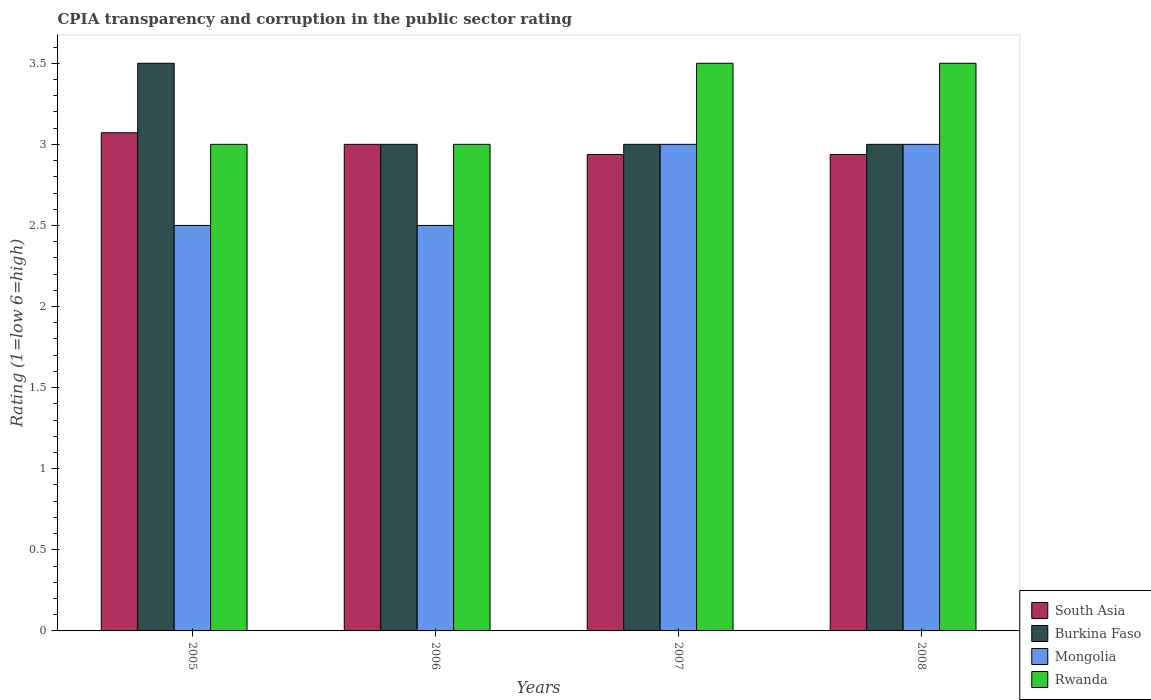How many different coloured bars are there?
Give a very brief answer. 4. Are the number of bars per tick equal to the number of legend labels?
Make the answer very short. Yes. How many bars are there on the 1st tick from the left?
Ensure brevity in your answer.  4. How many bars are there on the 4th tick from the right?
Your response must be concise. 4. What is the label of the 4th group of bars from the left?
Provide a short and direct response. 2008. In how many cases, is the number of bars for a given year not equal to the number of legend labels?
Keep it short and to the point. 0. What is the CPIA rating in Burkina Faso in 2008?
Provide a short and direct response. 3. Across all years, what is the maximum CPIA rating in Burkina Faso?
Make the answer very short. 3.5. Across all years, what is the minimum CPIA rating in South Asia?
Offer a terse response. 2.94. In which year was the CPIA rating in Burkina Faso maximum?
Provide a short and direct response. 2005. What is the difference between the CPIA rating in Burkina Faso in 2008 and the CPIA rating in South Asia in 2007?
Your answer should be very brief. 0.06. What is the average CPIA rating in Mongolia per year?
Provide a succinct answer. 2.75. In the year 2007, what is the difference between the CPIA rating in South Asia and CPIA rating in Burkina Faso?
Offer a terse response. -0.06. In how many years, is the CPIA rating in Mongolia greater than 1.6?
Ensure brevity in your answer.  4. What is the ratio of the CPIA rating in Mongolia in 2006 to that in 2007?
Your response must be concise. 0.83. Is the CPIA rating in Rwanda in 2005 less than that in 2007?
Your answer should be very brief. Yes. What is the difference between the highest and the second highest CPIA rating in Burkina Faso?
Provide a short and direct response. 0.5. What is the difference between the highest and the lowest CPIA rating in Rwanda?
Offer a very short reply. 0.5. Is it the case that in every year, the sum of the CPIA rating in Rwanda and CPIA rating in Mongolia is greater than the sum of CPIA rating in Burkina Faso and CPIA rating in South Asia?
Your answer should be very brief. No. What does the 4th bar from the left in 2008 represents?
Give a very brief answer. Rwanda. What does the 3rd bar from the right in 2008 represents?
Offer a very short reply. Burkina Faso. Is it the case that in every year, the sum of the CPIA rating in Mongolia and CPIA rating in Rwanda is greater than the CPIA rating in Burkina Faso?
Your response must be concise. Yes. How many bars are there?
Ensure brevity in your answer.  16. Are all the bars in the graph horizontal?
Your response must be concise. No. Are the values on the major ticks of Y-axis written in scientific E-notation?
Ensure brevity in your answer.  No. Does the graph contain any zero values?
Ensure brevity in your answer.  No. Where does the legend appear in the graph?
Ensure brevity in your answer.  Bottom right. How many legend labels are there?
Your answer should be compact. 4. How are the legend labels stacked?
Your answer should be compact. Vertical. What is the title of the graph?
Your response must be concise. CPIA transparency and corruption in the public sector rating. Does "Belarus" appear as one of the legend labels in the graph?
Keep it short and to the point. No. What is the label or title of the Y-axis?
Your answer should be very brief. Rating (1=low 6=high). What is the Rating (1=low 6=high) of South Asia in 2005?
Offer a very short reply. 3.07. What is the Rating (1=low 6=high) of Mongolia in 2005?
Provide a succinct answer. 2.5. What is the Rating (1=low 6=high) of Rwanda in 2005?
Offer a terse response. 3. What is the Rating (1=low 6=high) of Burkina Faso in 2006?
Ensure brevity in your answer.  3. What is the Rating (1=low 6=high) of Mongolia in 2006?
Make the answer very short. 2.5. What is the Rating (1=low 6=high) of Rwanda in 2006?
Offer a terse response. 3. What is the Rating (1=low 6=high) in South Asia in 2007?
Your answer should be very brief. 2.94. What is the Rating (1=low 6=high) of Mongolia in 2007?
Make the answer very short. 3. What is the Rating (1=low 6=high) in Rwanda in 2007?
Your response must be concise. 3.5. What is the Rating (1=low 6=high) in South Asia in 2008?
Your answer should be very brief. 2.94. What is the Rating (1=low 6=high) of Rwanda in 2008?
Your answer should be compact. 3.5. Across all years, what is the maximum Rating (1=low 6=high) in South Asia?
Offer a very short reply. 3.07. Across all years, what is the maximum Rating (1=low 6=high) of Mongolia?
Your answer should be compact. 3. Across all years, what is the maximum Rating (1=low 6=high) of Rwanda?
Ensure brevity in your answer.  3.5. Across all years, what is the minimum Rating (1=low 6=high) of South Asia?
Give a very brief answer. 2.94. Across all years, what is the minimum Rating (1=low 6=high) of Rwanda?
Offer a very short reply. 3. What is the total Rating (1=low 6=high) in South Asia in the graph?
Offer a very short reply. 11.95. What is the total Rating (1=low 6=high) in Burkina Faso in the graph?
Your answer should be compact. 12.5. What is the total Rating (1=low 6=high) of Mongolia in the graph?
Your answer should be compact. 11. What is the difference between the Rating (1=low 6=high) in South Asia in 2005 and that in 2006?
Offer a very short reply. 0.07. What is the difference between the Rating (1=low 6=high) of Burkina Faso in 2005 and that in 2006?
Keep it short and to the point. 0.5. What is the difference between the Rating (1=low 6=high) in Mongolia in 2005 and that in 2006?
Your response must be concise. 0. What is the difference between the Rating (1=low 6=high) of South Asia in 2005 and that in 2007?
Your response must be concise. 0.13. What is the difference between the Rating (1=low 6=high) of South Asia in 2005 and that in 2008?
Provide a short and direct response. 0.13. What is the difference between the Rating (1=low 6=high) in Rwanda in 2005 and that in 2008?
Give a very brief answer. -0.5. What is the difference between the Rating (1=low 6=high) of South Asia in 2006 and that in 2007?
Give a very brief answer. 0.06. What is the difference between the Rating (1=low 6=high) in Burkina Faso in 2006 and that in 2007?
Keep it short and to the point. 0. What is the difference between the Rating (1=low 6=high) of Mongolia in 2006 and that in 2007?
Give a very brief answer. -0.5. What is the difference between the Rating (1=low 6=high) in Rwanda in 2006 and that in 2007?
Make the answer very short. -0.5. What is the difference between the Rating (1=low 6=high) of South Asia in 2006 and that in 2008?
Offer a terse response. 0.06. What is the difference between the Rating (1=low 6=high) of Burkina Faso in 2006 and that in 2008?
Offer a terse response. 0. What is the difference between the Rating (1=low 6=high) of Mongolia in 2006 and that in 2008?
Provide a short and direct response. -0.5. What is the difference between the Rating (1=low 6=high) of South Asia in 2005 and the Rating (1=low 6=high) of Burkina Faso in 2006?
Keep it short and to the point. 0.07. What is the difference between the Rating (1=low 6=high) in South Asia in 2005 and the Rating (1=low 6=high) in Mongolia in 2006?
Your answer should be very brief. 0.57. What is the difference between the Rating (1=low 6=high) of South Asia in 2005 and the Rating (1=low 6=high) of Rwanda in 2006?
Provide a short and direct response. 0.07. What is the difference between the Rating (1=low 6=high) in Burkina Faso in 2005 and the Rating (1=low 6=high) in Mongolia in 2006?
Provide a succinct answer. 1. What is the difference between the Rating (1=low 6=high) of Mongolia in 2005 and the Rating (1=low 6=high) of Rwanda in 2006?
Provide a succinct answer. -0.5. What is the difference between the Rating (1=low 6=high) in South Asia in 2005 and the Rating (1=low 6=high) in Burkina Faso in 2007?
Your response must be concise. 0.07. What is the difference between the Rating (1=low 6=high) in South Asia in 2005 and the Rating (1=low 6=high) in Mongolia in 2007?
Provide a short and direct response. 0.07. What is the difference between the Rating (1=low 6=high) in South Asia in 2005 and the Rating (1=low 6=high) in Rwanda in 2007?
Ensure brevity in your answer.  -0.43. What is the difference between the Rating (1=low 6=high) of South Asia in 2005 and the Rating (1=low 6=high) of Burkina Faso in 2008?
Offer a very short reply. 0.07. What is the difference between the Rating (1=low 6=high) in South Asia in 2005 and the Rating (1=low 6=high) in Mongolia in 2008?
Offer a very short reply. 0.07. What is the difference between the Rating (1=low 6=high) in South Asia in 2005 and the Rating (1=low 6=high) in Rwanda in 2008?
Your response must be concise. -0.43. What is the difference between the Rating (1=low 6=high) in Burkina Faso in 2005 and the Rating (1=low 6=high) in Mongolia in 2008?
Offer a very short reply. 0.5. What is the difference between the Rating (1=low 6=high) of Mongolia in 2005 and the Rating (1=low 6=high) of Rwanda in 2008?
Make the answer very short. -1. What is the difference between the Rating (1=low 6=high) in South Asia in 2006 and the Rating (1=low 6=high) in Mongolia in 2007?
Make the answer very short. 0. What is the difference between the Rating (1=low 6=high) of Burkina Faso in 2006 and the Rating (1=low 6=high) of Rwanda in 2007?
Give a very brief answer. -0.5. What is the difference between the Rating (1=low 6=high) of South Asia in 2006 and the Rating (1=low 6=high) of Burkina Faso in 2008?
Your response must be concise. 0. What is the difference between the Rating (1=low 6=high) of South Asia in 2006 and the Rating (1=low 6=high) of Mongolia in 2008?
Your answer should be compact. 0. What is the difference between the Rating (1=low 6=high) in South Asia in 2006 and the Rating (1=low 6=high) in Rwanda in 2008?
Your response must be concise. -0.5. What is the difference between the Rating (1=low 6=high) of Burkina Faso in 2006 and the Rating (1=low 6=high) of Mongolia in 2008?
Your answer should be compact. 0. What is the difference between the Rating (1=low 6=high) in Burkina Faso in 2006 and the Rating (1=low 6=high) in Rwanda in 2008?
Provide a short and direct response. -0.5. What is the difference between the Rating (1=low 6=high) of Mongolia in 2006 and the Rating (1=low 6=high) of Rwanda in 2008?
Your answer should be compact. -1. What is the difference between the Rating (1=low 6=high) in South Asia in 2007 and the Rating (1=low 6=high) in Burkina Faso in 2008?
Keep it short and to the point. -0.06. What is the difference between the Rating (1=low 6=high) in South Asia in 2007 and the Rating (1=low 6=high) in Mongolia in 2008?
Give a very brief answer. -0.06. What is the difference between the Rating (1=low 6=high) of South Asia in 2007 and the Rating (1=low 6=high) of Rwanda in 2008?
Offer a very short reply. -0.56. What is the difference between the Rating (1=low 6=high) in Burkina Faso in 2007 and the Rating (1=low 6=high) in Rwanda in 2008?
Your response must be concise. -0.5. What is the average Rating (1=low 6=high) of South Asia per year?
Offer a terse response. 2.99. What is the average Rating (1=low 6=high) of Burkina Faso per year?
Your response must be concise. 3.12. What is the average Rating (1=low 6=high) of Mongolia per year?
Provide a short and direct response. 2.75. In the year 2005, what is the difference between the Rating (1=low 6=high) in South Asia and Rating (1=low 6=high) in Burkina Faso?
Your answer should be compact. -0.43. In the year 2005, what is the difference between the Rating (1=low 6=high) in South Asia and Rating (1=low 6=high) in Mongolia?
Keep it short and to the point. 0.57. In the year 2005, what is the difference between the Rating (1=low 6=high) of South Asia and Rating (1=low 6=high) of Rwanda?
Offer a terse response. 0.07. In the year 2005, what is the difference between the Rating (1=low 6=high) in Mongolia and Rating (1=low 6=high) in Rwanda?
Provide a succinct answer. -0.5. In the year 2006, what is the difference between the Rating (1=low 6=high) of South Asia and Rating (1=low 6=high) of Burkina Faso?
Give a very brief answer. 0. In the year 2006, what is the difference between the Rating (1=low 6=high) of Burkina Faso and Rating (1=low 6=high) of Rwanda?
Your answer should be compact. 0. In the year 2006, what is the difference between the Rating (1=low 6=high) in Mongolia and Rating (1=low 6=high) in Rwanda?
Give a very brief answer. -0.5. In the year 2007, what is the difference between the Rating (1=low 6=high) in South Asia and Rating (1=low 6=high) in Burkina Faso?
Your answer should be compact. -0.06. In the year 2007, what is the difference between the Rating (1=low 6=high) in South Asia and Rating (1=low 6=high) in Mongolia?
Make the answer very short. -0.06. In the year 2007, what is the difference between the Rating (1=low 6=high) of South Asia and Rating (1=low 6=high) of Rwanda?
Your answer should be compact. -0.56. In the year 2007, what is the difference between the Rating (1=low 6=high) in Burkina Faso and Rating (1=low 6=high) in Rwanda?
Make the answer very short. -0.5. In the year 2007, what is the difference between the Rating (1=low 6=high) in Mongolia and Rating (1=low 6=high) in Rwanda?
Make the answer very short. -0.5. In the year 2008, what is the difference between the Rating (1=low 6=high) of South Asia and Rating (1=low 6=high) of Burkina Faso?
Make the answer very short. -0.06. In the year 2008, what is the difference between the Rating (1=low 6=high) of South Asia and Rating (1=low 6=high) of Mongolia?
Keep it short and to the point. -0.06. In the year 2008, what is the difference between the Rating (1=low 6=high) of South Asia and Rating (1=low 6=high) of Rwanda?
Give a very brief answer. -0.56. In the year 2008, what is the difference between the Rating (1=low 6=high) in Burkina Faso and Rating (1=low 6=high) in Rwanda?
Your answer should be compact. -0.5. In the year 2008, what is the difference between the Rating (1=low 6=high) of Mongolia and Rating (1=low 6=high) of Rwanda?
Ensure brevity in your answer.  -0.5. What is the ratio of the Rating (1=low 6=high) in South Asia in 2005 to that in 2006?
Ensure brevity in your answer.  1.02. What is the ratio of the Rating (1=low 6=high) in Mongolia in 2005 to that in 2006?
Provide a short and direct response. 1. What is the ratio of the Rating (1=low 6=high) of South Asia in 2005 to that in 2007?
Make the answer very short. 1.05. What is the ratio of the Rating (1=low 6=high) of Burkina Faso in 2005 to that in 2007?
Keep it short and to the point. 1.17. What is the ratio of the Rating (1=low 6=high) of Mongolia in 2005 to that in 2007?
Offer a terse response. 0.83. What is the ratio of the Rating (1=low 6=high) in South Asia in 2005 to that in 2008?
Make the answer very short. 1.05. What is the ratio of the Rating (1=low 6=high) of Mongolia in 2005 to that in 2008?
Offer a very short reply. 0.83. What is the ratio of the Rating (1=low 6=high) in South Asia in 2006 to that in 2007?
Your answer should be very brief. 1.02. What is the ratio of the Rating (1=low 6=high) in Rwanda in 2006 to that in 2007?
Offer a very short reply. 0.86. What is the ratio of the Rating (1=low 6=high) in South Asia in 2006 to that in 2008?
Give a very brief answer. 1.02. What is the ratio of the Rating (1=low 6=high) of Burkina Faso in 2006 to that in 2008?
Keep it short and to the point. 1. What is the ratio of the Rating (1=low 6=high) in Mongolia in 2006 to that in 2008?
Offer a very short reply. 0.83. What is the ratio of the Rating (1=low 6=high) of Rwanda in 2006 to that in 2008?
Provide a short and direct response. 0.86. What is the ratio of the Rating (1=low 6=high) of South Asia in 2007 to that in 2008?
Offer a terse response. 1. What is the ratio of the Rating (1=low 6=high) in Mongolia in 2007 to that in 2008?
Offer a very short reply. 1. What is the ratio of the Rating (1=low 6=high) of Rwanda in 2007 to that in 2008?
Your answer should be compact. 1. What is the difference between the highest and the second highest Rating (1=low 6=high) in South Asia?
Provide a succinct answer. 0.07. What is the difference between the highest and the second highest Rating (1=low 6=high) of Burkina Faso?
Your response must be concise. 0.5. What is the difference between the highest and the lowest Rating (1=low 6=high) in South Asia?
Offer a very short reply. 0.13. What is the difference between the highest and the lowest Rating (1=low 6=high) in Mongolia?
Ensure brevity in your answer.  0.5. 